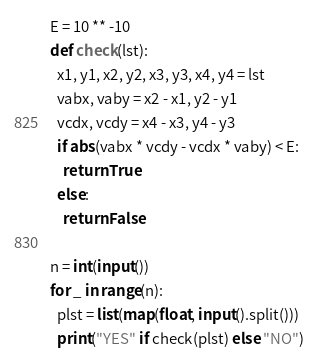Convert code to text. <code><loc_0><loc_0><loc_500><loc_500><_Python_>E = 10 ** -10
def check(lst):
  x1, y1, x2, y2, x3, y3, x4, y4 = lst
  vabx, vaby = x2 - x1, y2 - y1
  vcdx, vcdy = x4 - x3, y4 - y3
  if abs(vabx * vcdy - vcdx * vaby) < E:
    return True
  else:
    return False

n = int(input())
for _ in range(n):
  plst = list(map(float, input().split()))
  print("YES" if check(plst) else "NO")
</code> 